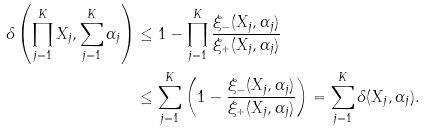Convert formula to latex. <formula><loc_0><loc_0><loc_500><loc_500>\delta \left ( \prod _ { j = 1 } ^ { K } X _ { j } , \sum _ { j = 1 } ^ { K } \alpha _ { j } \right ) & \leq 1 - \prod _ { j = 1 } ^ { K } \frac { \xi _ { - } ( X _ { j } , \alpha _ { j } ) } { \xi _ { + } ( X _ { j } , \alpha _ { j } ) } \\ & \leq \sum _ { j = 1 } ^ { K } \left ( 1 - \frac { \xi _ { - } ( X _ { j } , \alpha _ { j } ) } { \xi _ { + } ( X _ { j } , \alpha _ { j } ) } \right ) = \sum _ { j = 1 } ^ { K } \delta ( X _ { j } , \alpha _ { j } ) .</formula> 